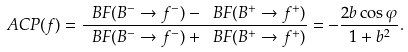<formula> <loc_0><loc_0><loc_500><loc_500>\ A C P ( f ) = \frac { \ B F ( B ^ { - } \to f ^ { - } ) - \ B F ( B ^ { + } \to f ^ { + } ) } { \ B F ( B ^ { - } \to f ^ { - } ) + \ B F ( B ^ { + } \to f ^ { + } ) } = - \frac { 2 b \cos \varphi } { 1 + b ^ { 2 } } .</formula> 